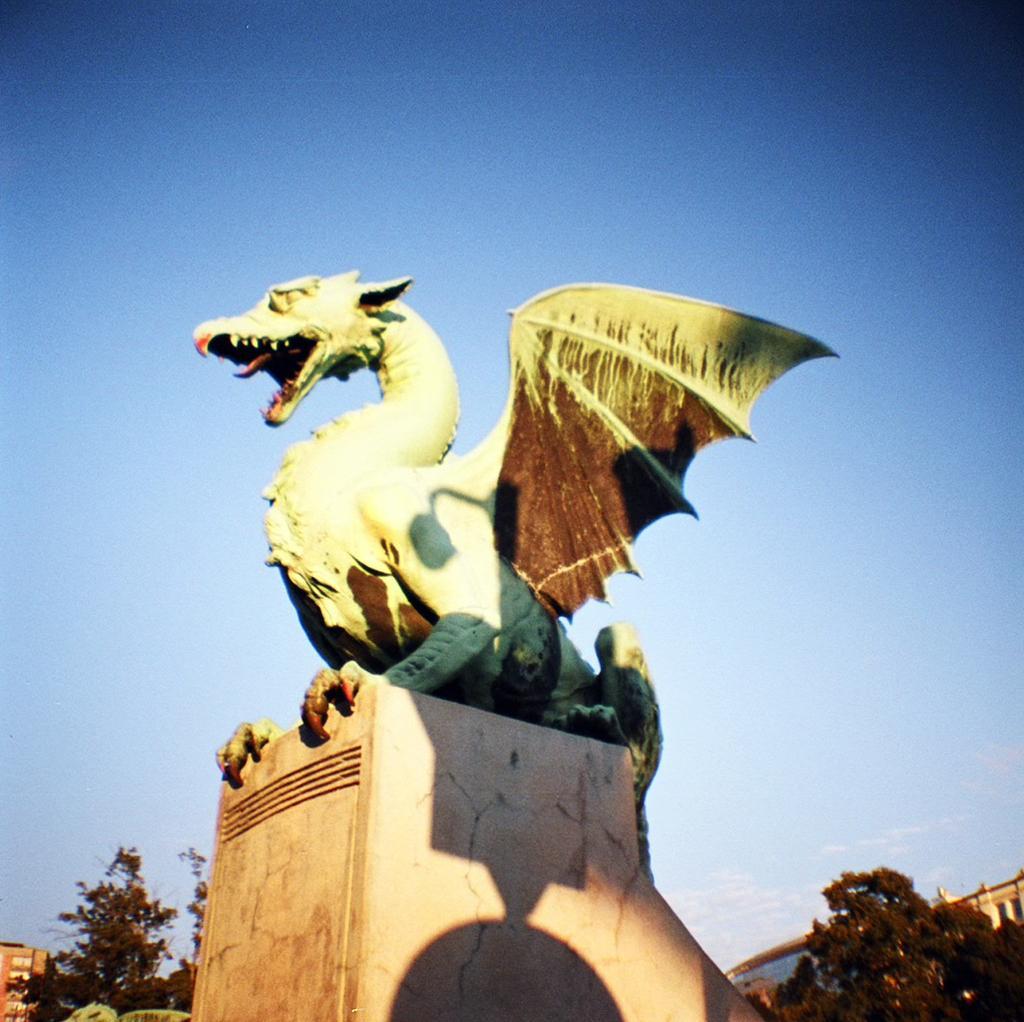In one or two sentences, can you explain what this image depicts? In the foreground, I can see a sculpture of an animal and I can see plants and trees. In the background, I can see buildings and the sky. This picture might be taken in a day. 